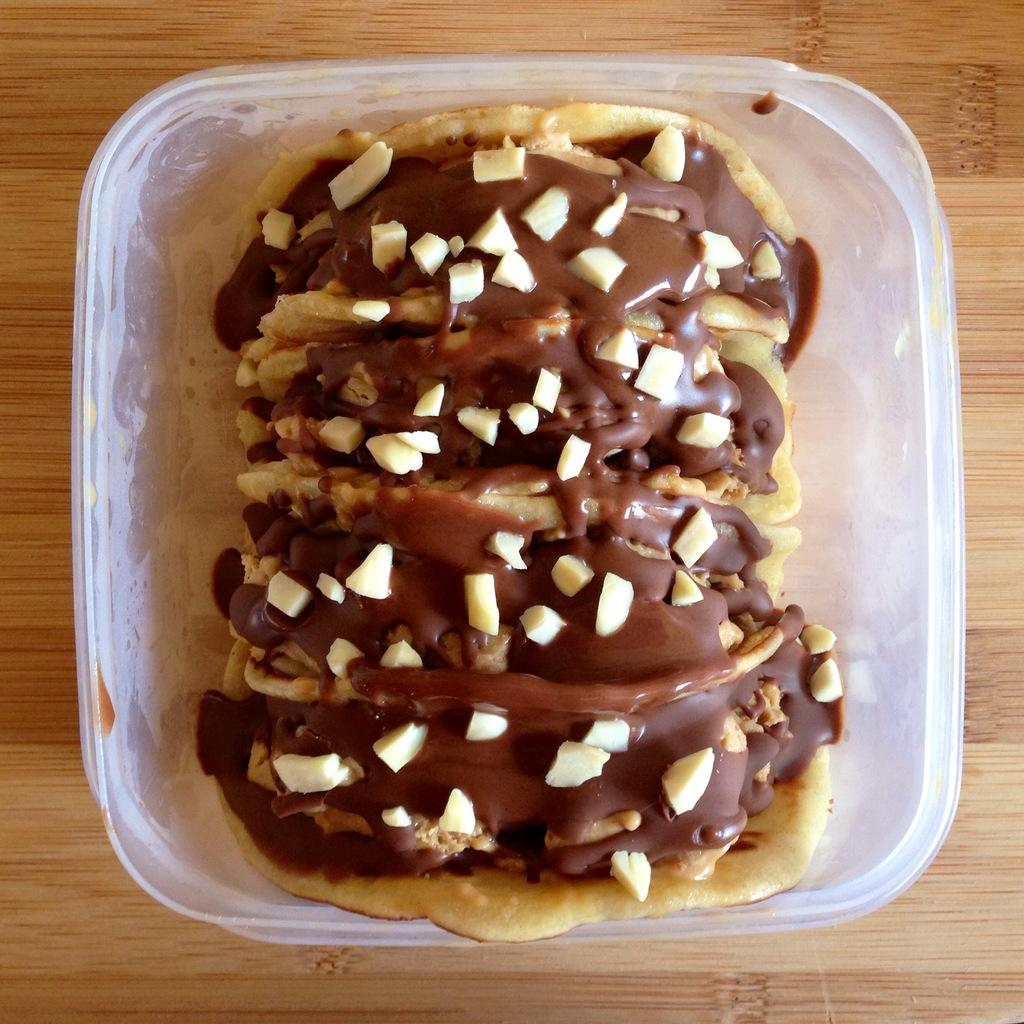What is in the bowl that is visible in the image? There is a food item in the bowl in the image. Where is the bowl located in the image? The bowl is placed on a table in the image. What book is the person reading in the image? There is no person or book present in the image; it only features a bowl with a food item on a table. 